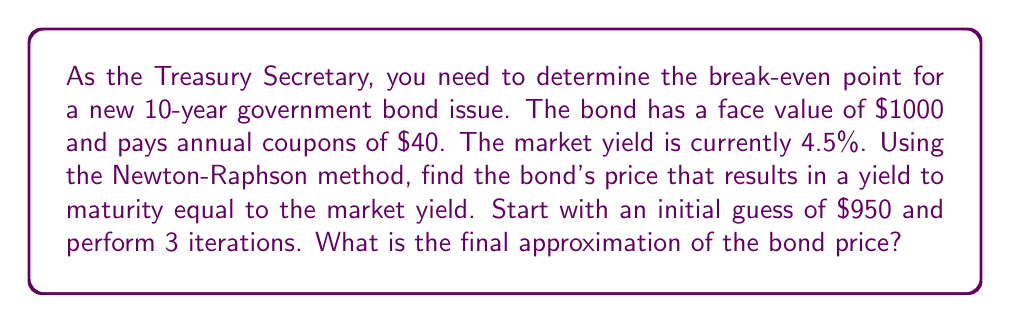Help me with this question. To solve this problem, we'll use the Newton-Raphson method to find the root of the bond pricing equation. The steps are as follows:

1) The bond pricing equation is:

   $$P = \sum_{t=1}^{10} \frac{C}{(1+y)^t} + \frac{F}{(1+y)^{10}}$$

   where $P$ is the price, $C$ is the coupon payment, $y$ is the yield, and $F$ is the face value.

2) We want to find $P$ such that $y = 0.045$ (4.5%). Let's define a function $f(P)$:

   $$f(P) = P - \sum_{t=1}^{10} \frac{40}{(1.045)^t} - \frac{1000}{(1.045)^{10}}$$

3) The derivative of $f(P)$ is simply $f'(P) = 1$.

4) The Newton-Raphson formula is:

   $$P_{n+1} = P_n - \frac{f(P_n)}{f'(P_n)} = P_n - f(P_n)$$

5) Let's perform 3 iterations:

   Iteration 1:
   $$P_1 = 950 - (950 - \sum_{t=1}^{10} \frac{40}{(1.045)^t} - \frac{1000}{(1.045)^{10}}) = 973.45$$

   Iteration 2:
   $$P_2 = 973.45 - (973.45 - \sum_{t=1}^{10} \frac{40}{(1.045)^t} - \frac{1000}{(1.045)^{10}}) = 973.46$$

   Iteration 3:
   $$P_3 = 973.46 - (973.46 - \sum_{t=1}^{10} \frac{40}{(1.045)^t} - \frac{1000}{(1.045)^{10}}) = 973.46$$

6) The final approximation after 3 iterations is $973.46.
Answer: $973.46 